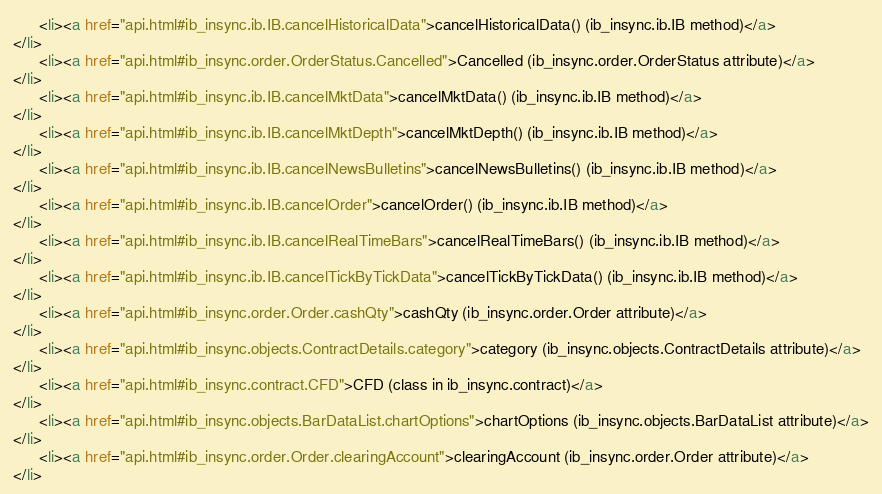<code> <loc_0><loc_0><loc_500><loc_500><_HTML_>      <li><a href="api.html#ib_insync.ib.IB.cancelHistoricalData">cancelHistoricalData() (ib_insync.ib.IB method)</a>
</li>
      <li><a href="api.html#ib_insync.order.OrderStatus.Cancelled">Cancelled (ib_insync.order.OrderStatus attribute)</a>
</li>
      <li><a href="api.html#ib_insync.ib.IB.cancelMktData">cancelMktData() (ib_insync.ib.IB method)</a>
</li>
      <li><a href="api.html#ib_insync.ib.IB.cancelMktDepth">cancelMktDepth() (ib_insync.ib.IB method)</a>
</li>
      <li><a href="api.html#ib_insync.ib.IB.cancelNewsBulletins">cancelNewsBulletins() (ib_insync.ib.IB method)</a>
</li>
      <li><a href="api.html#ib_insync.ib.IB.cancelOrder">cancelOrder() (ib_insync.ib.IB method)</a>
</li>
      <li><a href="api.html#ib_insync.ib.IB.cancelRealTimeBars">cancelRealTimeBars() (ib_insync.ib.IB method)</a>
</li>
      <li><a href="api.html#ib_insync.ib.IB.cancelTickByTickData">cancelTickByTickData() (ib_insync.ib.IB method)</a>
</li>
      <li><a href="api.html#ib_insync.order.Order.cashQty">cashQty (ib_insync.order.Order attribute)</a>
</li>
      <li><a href="api.html#ib_insync.objects.ContractDetails.category">category (ib_insync.objects.ContractDetails attribute)</a>
</li>
      <li><a href="api.html#ib_insync.contract.CFD">CFD (class in ib_insync.contract)</a>
</li>
      <li><a href="api.html#ib_insync.objects.BarDataList.chartOptions">chartOptions (ib_insync.objects.BarDataList attribute)</a>
</li>
      <li><a href="api.html#ib_insync.order.Order.clearingAccount">clearingAccount (ib_insync.order.Order attribute)</a>
</li></code> 